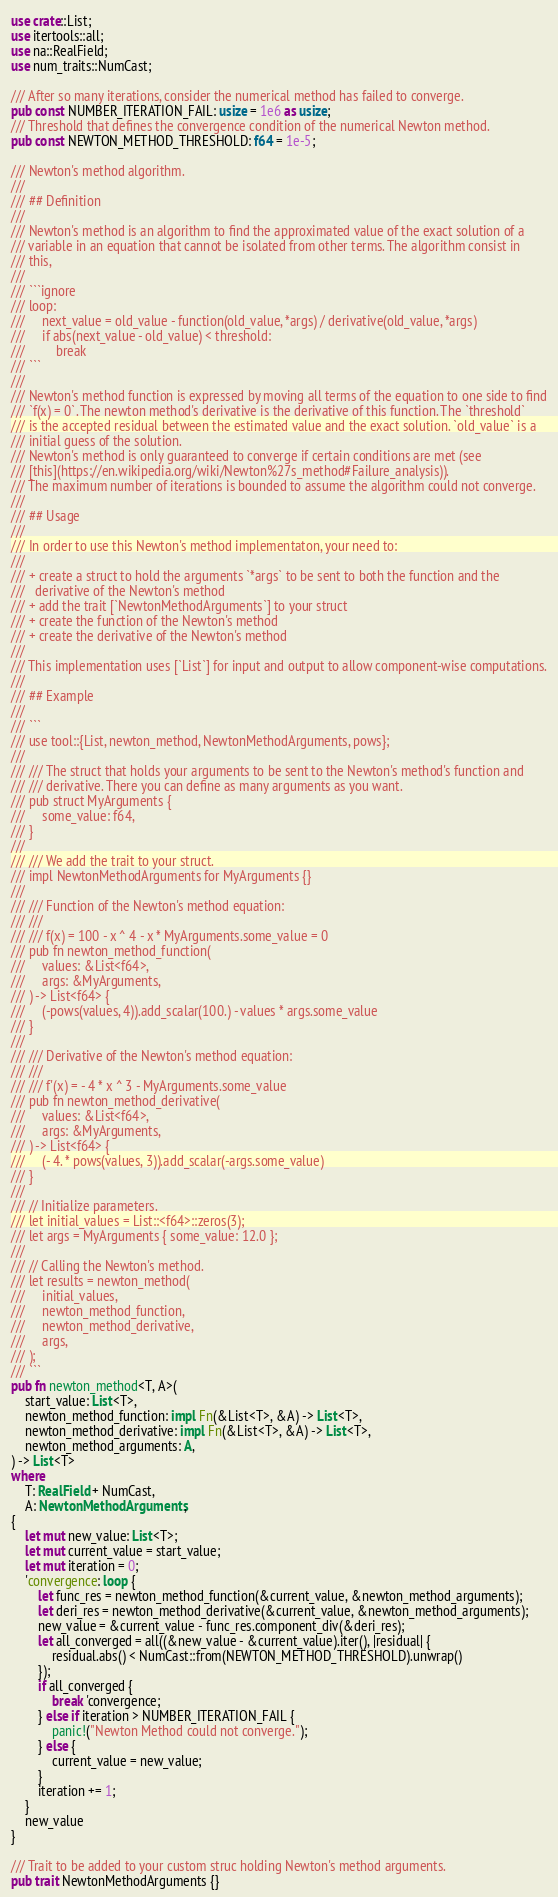Convert code to text. <code><loc_0><loc_0><loc_500><loc_500><_Rust_>use crate::List;
use itertools::all;
use na::RealField;
use num_traits::NumCast;

/// After so many iterations, consider the numerical method has failed to converge.
pub const NUMBER_ITERATION_FAIL: usize = 1e6 as usize;
/// Threshold that defines the convergence condition of the numerical Newton method.
pub const NEWTON_METHOD_THRESHOLD: f64 = 1e-5;

/// Newton's method algorithm.
///
/// ## Definition
///
/// Newton's method is an algorithm to find the approximated value of the exact solution of a
/// variable in an equation that cannot be isolated from other terms. The algorithm consist in
/// this,
///
/// ```ignore
/// loop:
///     next_value = old_value - function(old_value, *args) / derivative(old_value, *args)
///     if abs(next_value - old_value) < threshold:
///         break
/// ```
///
/// Newton's method function is expressed by moving all terms of the equation to one side to find
/// `f(x) = 0`. The newton method's derivative is the derivative of this function. The `threshold`
/// is the accepted residual between the estimated value and the exact solution. `old_value` is a
/// initial guess of the solution.
/// Newton's method is only guaranteed to converge if certain conditions are met (see
/// [this](https://en.wikipedia.org/wiki/Newton%27s_method#Failure_analysis)).
/// The maximum number of iterations is bounded to assume the algorithm could not converge.
///
/// ## Usage
///
/// In order to use this Newton's method implementaton, your need to:
///
/// + create a struct to hold the arguments `*args` to be sent to both the function and the
///   derivative of the Newton's method
/// + add the trait [`NewtonMethodArguments`] to your struct
/// + create the function of the Newton's method
/// + create the derivative of the Newton's method
///
/// This implementation uses [`List`] for input and output to allow component-wise computations.
///
/// ## Example
///
/// ```
/// use tool::{List, newton_method, NewtonMethodArguments, pows};
///
/// /// The struct that holds your arguments to be sent to the Newton's method's function and
/// /// derivative. There you can define as many arguments as you want.
/// pub struct MyArguments {
///     some_value: f64,
/// }
///
/// /// We add the trait to your struct.
/// impl NewtonMethodArguments for MyArguments {}
///
/// /// Function of the Newton's method equation:
/// ///
/// /// f(x) = 100 - x ^ 4 - x * MyArguments.some_value = 0
/// pub fn newton_method_function(
///     values: &List<f64>,
///     args: &MyArguments,
/// ) -> List<f64> {
///     (-pows(values, 4)).add_scalar(100.) - values * args.some_value
/// }
///
/// /// Derivative of the Newton's method equation:
/// ///
/// /// f'(x) = - 4 * x ^ 3 - MyArguments.some_value
/// pub fn newton_method_derivative(
///     values: &List<f64>,
///     args: &MyArguments,
/// ) -> List<f64> {
///     (- 4. * pows(values, 3)).add_scalar(-args.some_value)
/// }
///
/// // Initialize parameters.
/// let initial_values = List::<f64>::zeros(3);
/// let args = MyArguments { some_value: 12.0 };
///
/// // Calling the Newton's method.
/// let results = newton_method(
///     initial_values,
///     newton_method_function,
///     newton_method_derivative,
///     args,
/// );
/// ```
pub fn newton_method<T, A>(
    start_value: List<T>,
    newton_method_function: impl Fn(&List<T>, &A) -> List<T>,
    newton_method_derivative: impl Fn(&List<T>, &A) -> List<T>,
    newton_method_arguments: A,
) -> List<T>
where
    T: RealField + NumCast,
    A: NewtonMethodArguments,
{
    let mut new_value: List<T>;
    let mut current_value = start_value;
    let mut iteration = 0;
    'convergence: loop {
        let func_res = newton_method_function(&current_value, &newton_method_arguments);
        let deri_res = newton_method_derivative(&current_value, &newton_method_arguments);
        new_value = &current_value - func_res.component_div(&deri_res);
        let all_converged = all((&new_value - &current_value).iter(), |residual| {
            residual.abs() < NumCast::from(NEWTON_METHOD_THRESHOLD).unwrap()
        });
        if all_converged {
            break 'convergence;
        } else if iteration > NUMBER_ITERATION_FAIL {
            panic!("Newton Method could not converge.");
        } else {
            current_value = new_value;
        }
        iteration += 1;
    }
    new_value
}

/// Trait to be added to your custom struc holding Newton's method arguments.
pub trait NewtonMethodArguments {}
</code> 